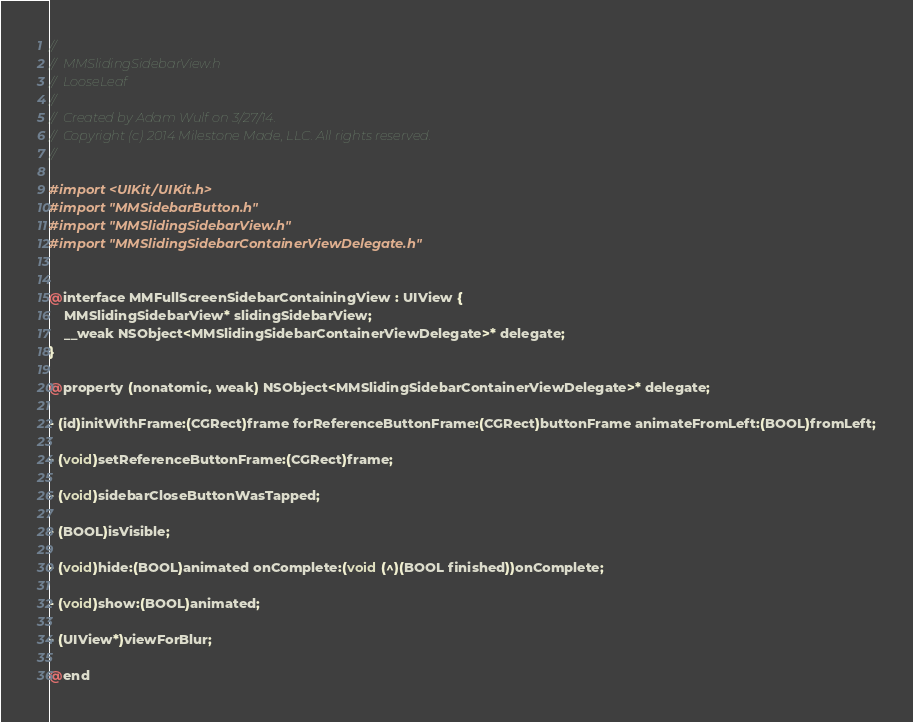Convert code to text. <code><loc_0><loc_0><loc_500><loc_500><_C_>//
//  MMSlidingSidebarView.h
//  LooseLeaf
//
//  Created by Adam Wulf on 3/27/14.
//  Copyright (c) 2014 Milestone Made, LLC. All rights reserved.
//

#import <UIKit/UIKit.h>
#import "MMSidebarButton.h"
#import "MMSlidingSidebarView.h"
#import "MMSlidingSidebarContainerViewDelegate.h"


@interface MMFullScreenSidebarContainingView : UIView {
    MMSlidingSidebarView* slidingSidebarView;
    __weak NSObject<MMSlidingSidebarContainerViewDelegate>* delegate;
}

@property (nonatomic, weak) NSObject<MMSlidingSidebarContainerViewDelegate>* delegate;

- (id)initWithFrame:(CGRect)frame forReferenceButtonFrame:(CGRect)buttonFrame animateFromLeft:(BOOL)fromLeft;

- (void)setReferenceButtonFrame:(CGRect)frame;

- (void)sidebarCloseButtonWasTapped;

- (BOOL)isVisible;

- (void)hide:(BOOL)animated onComplete:(void (^)(BOOL finished))onComplete;

- (void)show:(BOOL)animated;

- (UIView*)viewForBlur;

@end
</code> 